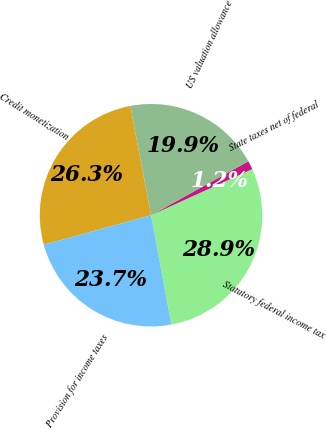Convert chart to OTSL. <chart><loc_0><loc_0><loc_500><loc_500><pie_chart><fcel>Statutory federal income tax<fcel>State taxes net of federal<fcel>US valuation allowance<fcel>Credit monetization<fcel>Provision for income taxes<nl><fcel>28.89%<fcel>1.25%<fcel>19.93%<fcel>26.28%<fcel>23.66%<nl></chart> 